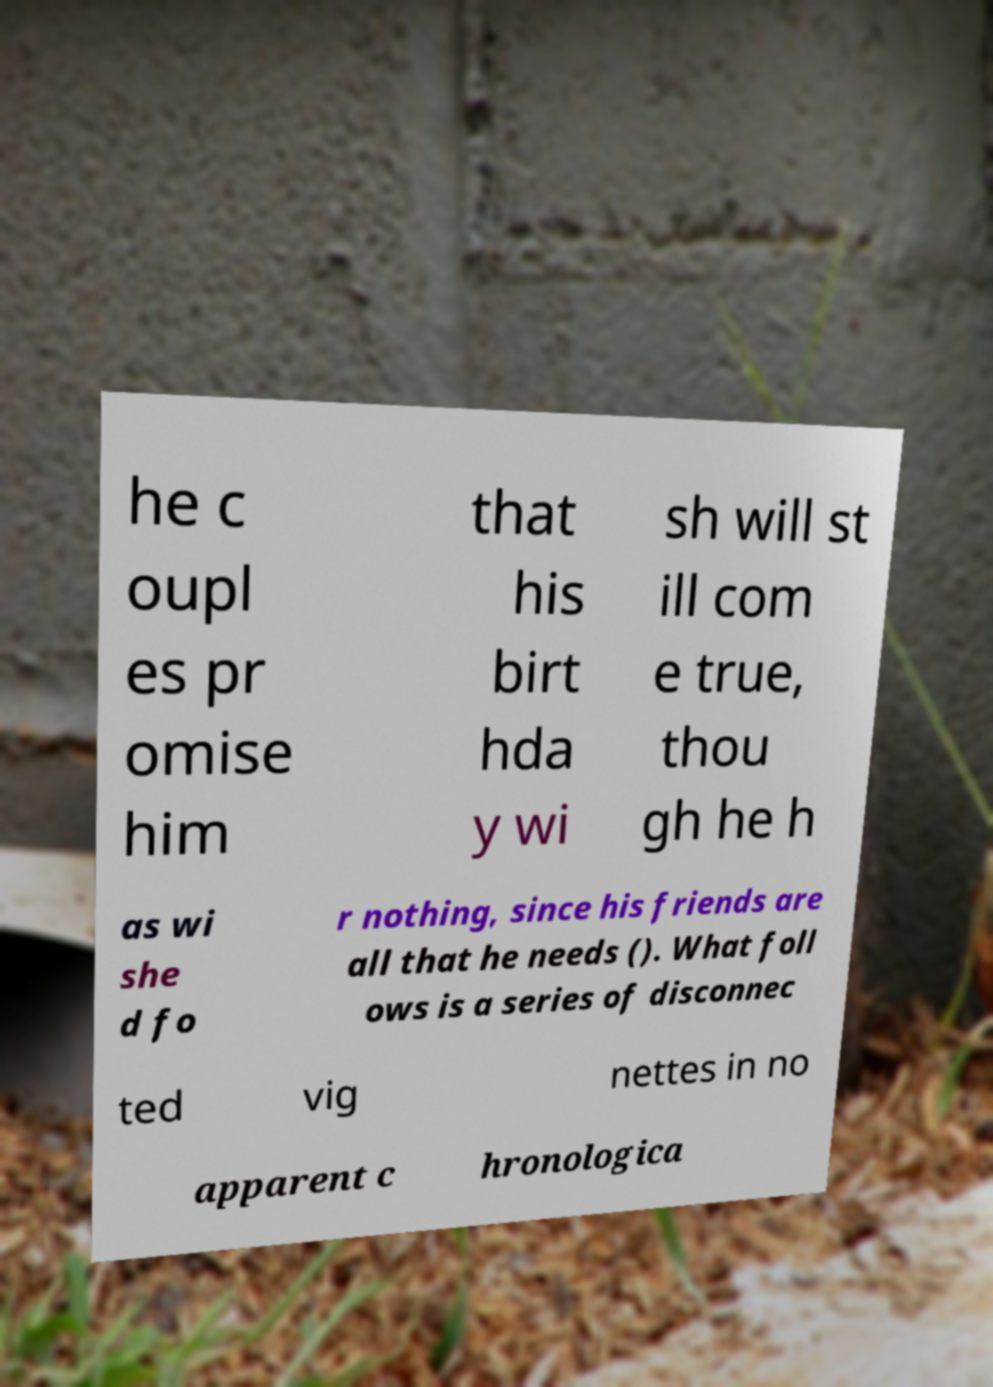I need the written content from this picture converted into text. Can you do that? he c oupl es pr omise him that his birt hda y wi sh will st ill com e true, thou gh he h as wi she d fo r nothing, since his friends are all that he needs (). What foll ows is a series of disconnec ted vig nettes in no apparent c hronologica 